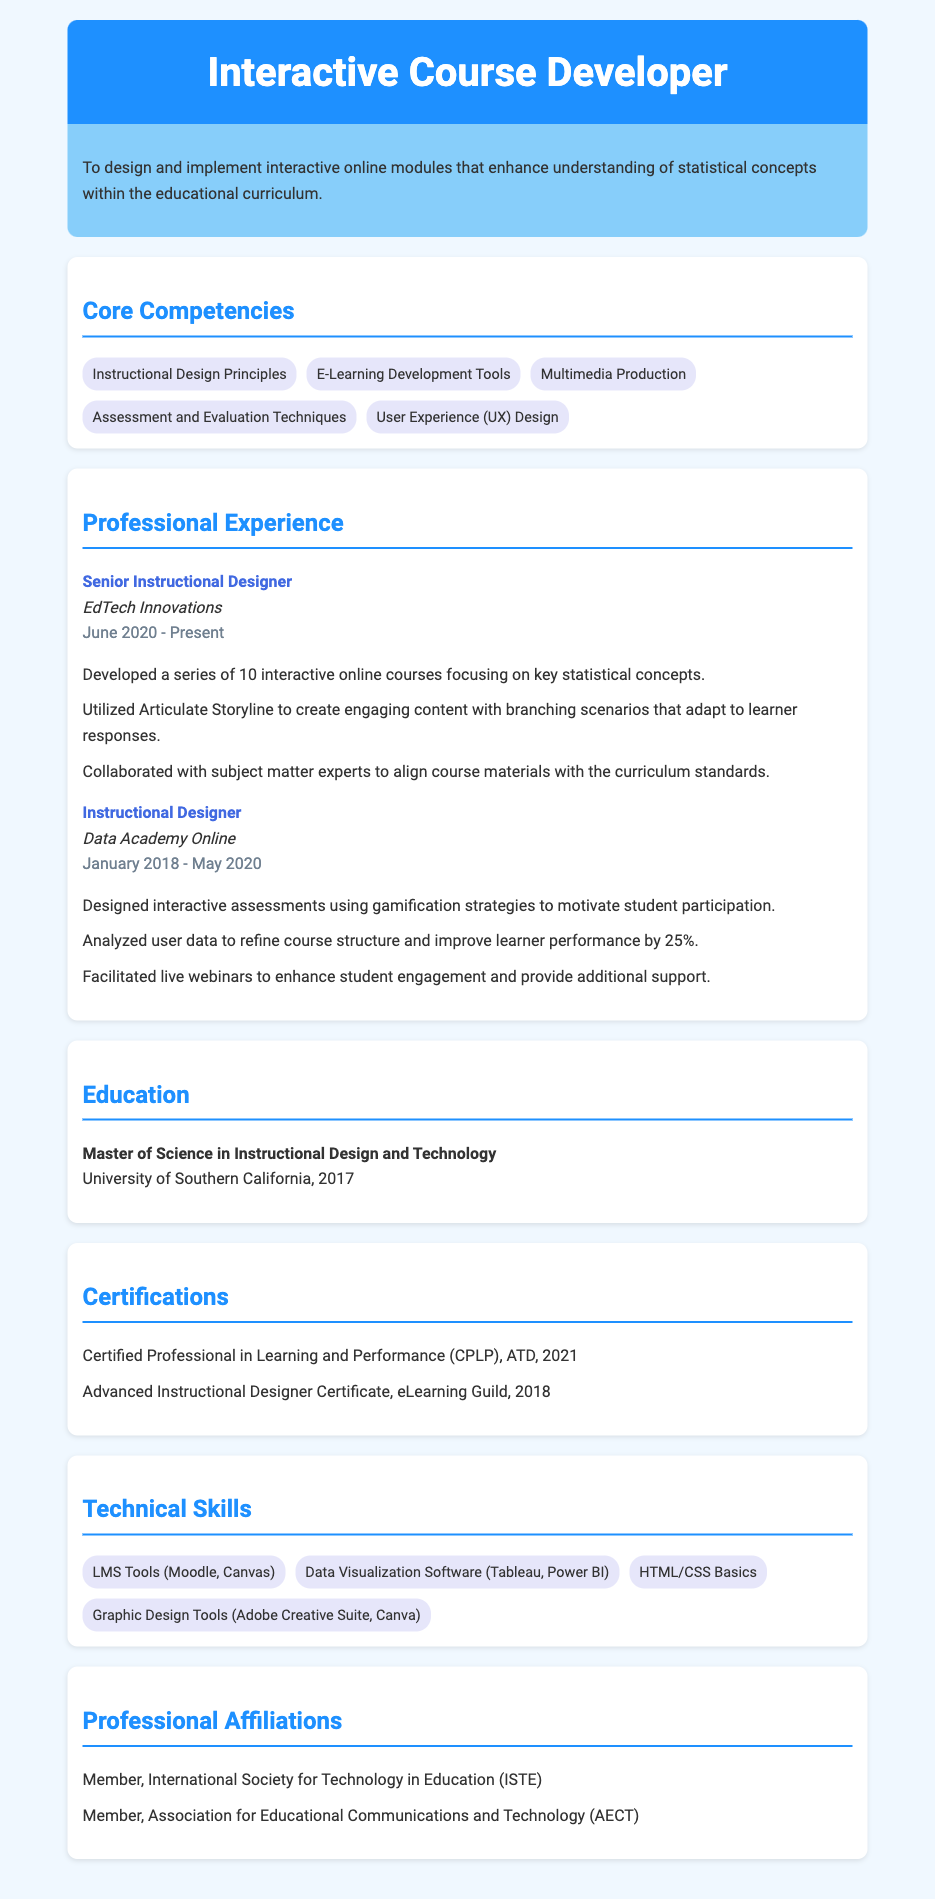what is the job title listed under current employment? The job title is displayed in the Professional Experience section, specifically mentioning the current position at EdTech Innovations.
Answer: Senior Instructional Designer which company did the individual work for from January 2018 to May 2020? This information can be obtained from the duration section of the Professional Experience area, linked to the previous job title.
Answer: Data Academy Online how many interactive online courses were developed at EdTech Innovations? The total number of courses is specifically mentioned in the job responsibilities under the Senior Instructional Designer role.
Answer: 10 what is the highest degree obtained by the individual? This answer can be found in the Education section, where the individual’s educational qualifications are outlined.
Answer: Master of Science in Instructional Design and Technology what certification was obtained in 2021? The certifications acquired are listed in a separate section, providing specific details about when they were obtained.
Answer: Certified Professional in Learning and Performance what is one of the core competencies related to course design? The Core Competencies section lists various skills and principles directly related to instructional design.
Answer: Instructional Design Principles how much did learner performance improve due to refined course structure? This metric is mentioned in the job responsibilities under the Instructional Designer position at Data Academy Online.
Answer: 25% which media tools are mentioned in the technical skills section? The Technical Skills section includes various tools used for multimedia and web design, which can be identified easily.
Answer: Adobe Creative Suite, Canva 